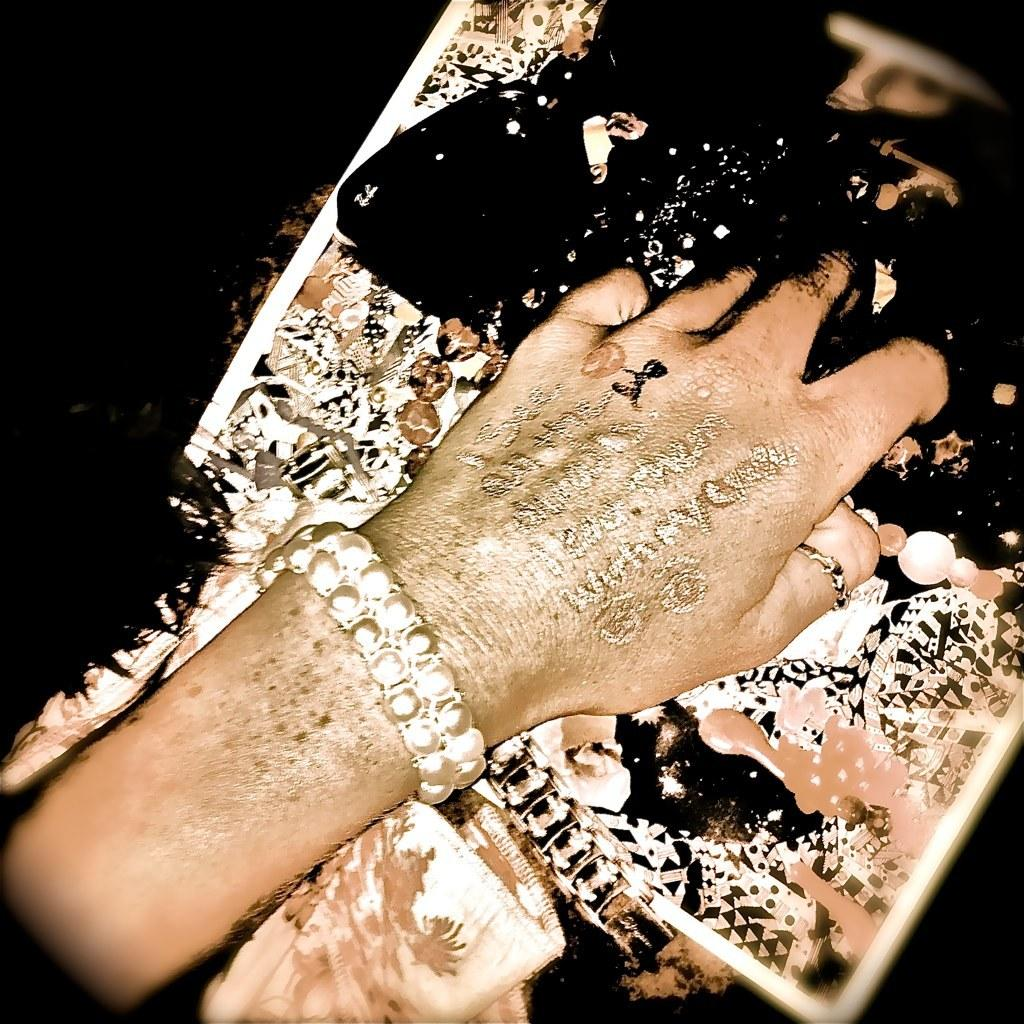What is the main subject of the image? The main subject of the image is a hand. Can you describe the appearance of the hand? The hand has color on it, and there is text written on it. What else can be seen in the image besides the hand? Jewelry is present in the image. What type of chain can be seen connecting the hand to the brick in the image? There is no chain or brick present in the image; it only features a hand with color and text, along with jewelry. 